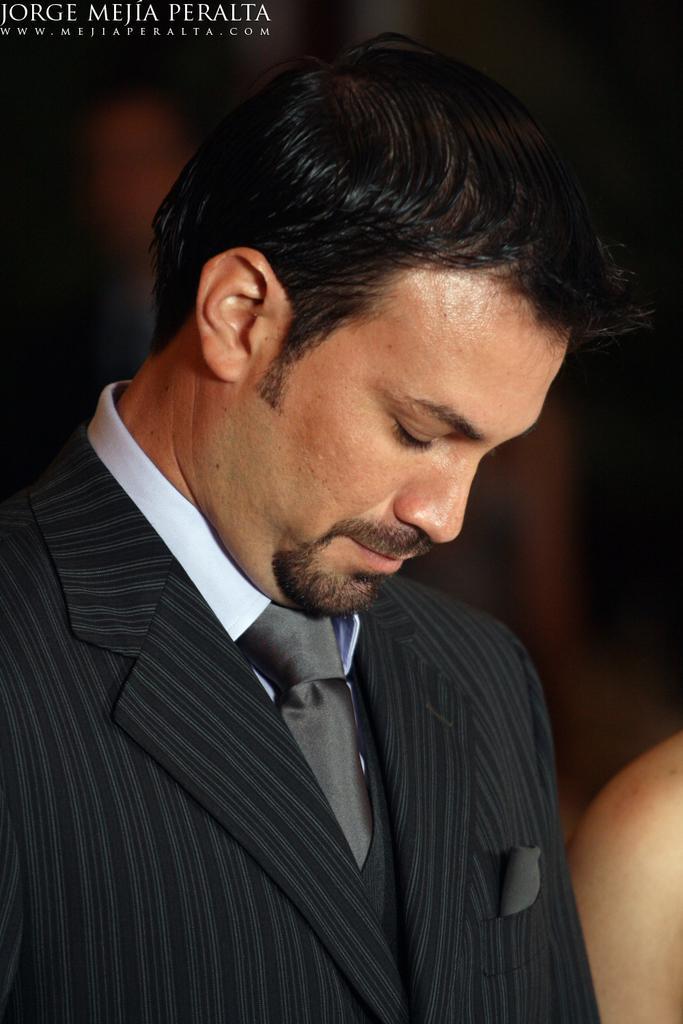Could you give a brief overview of what you see in this image? In the front of the image I can see a person. In the background of the image it is blurry. At the top left side of the image there is a watermark. 